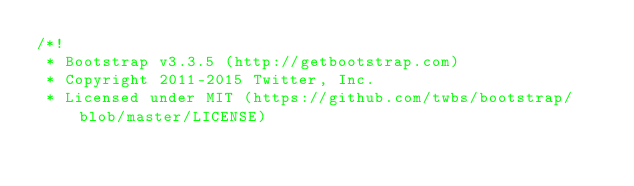<code> <loc_0><loc_0><loc_500><loc_500><_CSS_>/*!
 * Bootstrap v3.3.5 (http://getbootstrap.com)
 * Copyright 2011-2015 Twitter, Inc.
 * Licensed under MIT (https://github.com/twbs/bootstrap/blob/master/LICENSE)</code> 